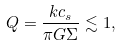Convert formula to latex. <formula><loc_0><loc_0><loc_500><loc_500>Q = \frac { k c _ { s } } { \pi G \Sigma } \lesssim 1 ,</formula> 